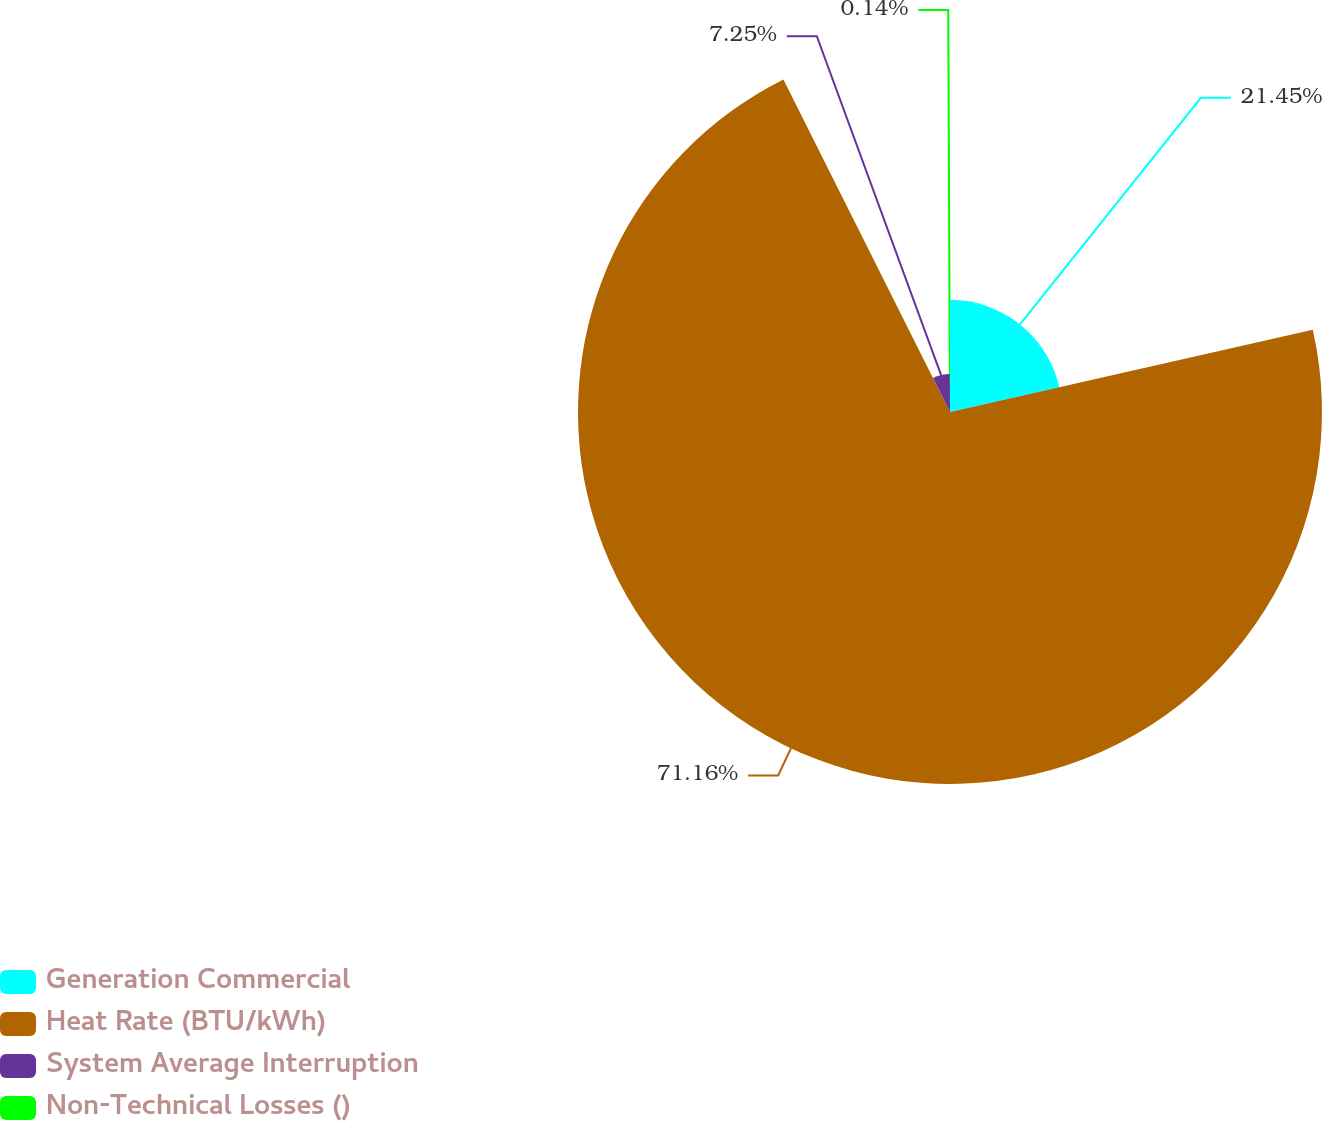Convert chart. <chart><loc_0><loc_0><loc_500><loc_500><pie_chart><fcel>Generation Commercial<fcel>Heat Rate (BTU/kWh)<fcel>System Average Interruption<fcel>Non-Technical Losses ()<nl><fcel>21.45%<fcel>71.16%<fcel>7.25%<fcel>0.14%<nl></chart> 